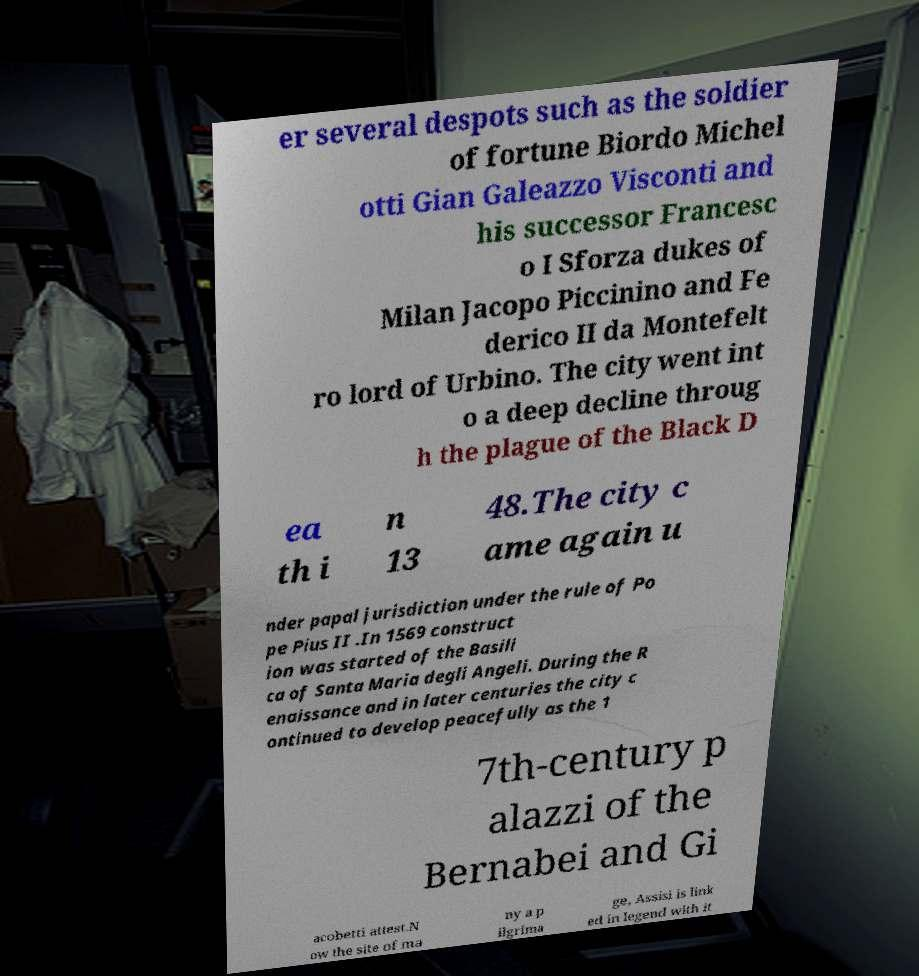Please read and relay the text visible in this image. What does it say? er several despots such as the soldier of fortune Biordo Michel otti Gian Galeazzo Visconti and his successor Francesc o I Sforza dukes of Milan Jacopo Piccinino and Fe derico II da Montefelt ro lord of Urbino. The city went int o a deep decline throug h the plague of the Black D ea th i n 13 48.The city c ame again u nder papal jurisdiction under the rule of Po pe Pius II .In 1569 construct ion was started of the Basili ca of Santa Maria degli Angeli. During the R enaissance and in later centuries the city c ontinued to develop peacefully as the 1 7th-century p alazzi of the Bernabei and Gi acobetti attest.N ow the site of ma ny a p ilgrima ge, Assisi is link ed in legend with it 